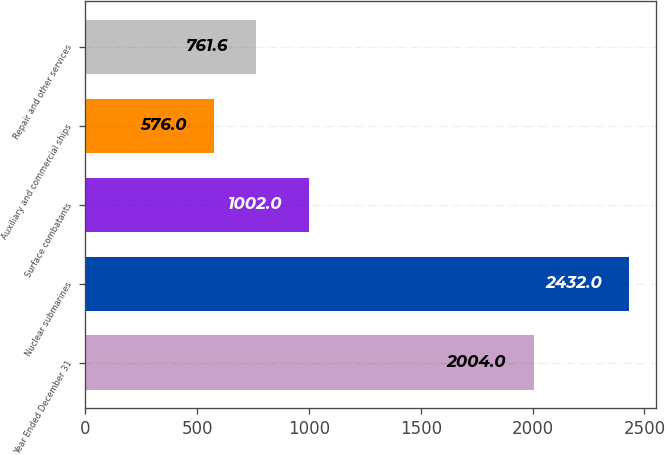<chart> <loc_0><loc_0><loc_500><loc_500><bar_chart><fcel>Year Ended December 31<fcel>Nuclear submarines<fcel>Surface combatants<fcel>Auxiliary and commercial ships<fcel>Repair and other services<nl><fcel>2004<fcel>2432<fcel>1002<fcel>576<fcel>761.6<nl></chart> 